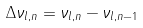Convert formula to latex. <formula><loc_0><loc_0><loc_500><loc_500>\Delta \nu _ { l , n } = \nu _ { l , n } - \nu _ { l , n - 1 }</formula> 